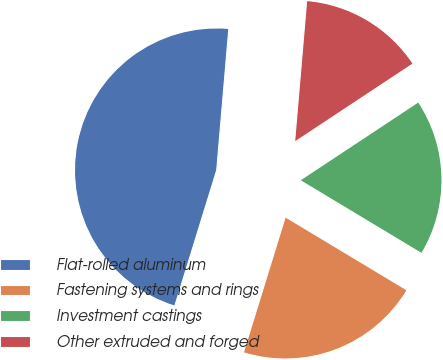Convert chart. <chart><loc_0><loc_0><loc_500><loc_500><pie_chart><fcel>Flat-rolled aluminum<fcel>Fastening systems and rings<fcel>Investment castings<fcel>Other extruded and forged<nl><fcel>46.59%<fcel>21.15%<fcel>17.92%<fcel>14.34%<nl></chart> 